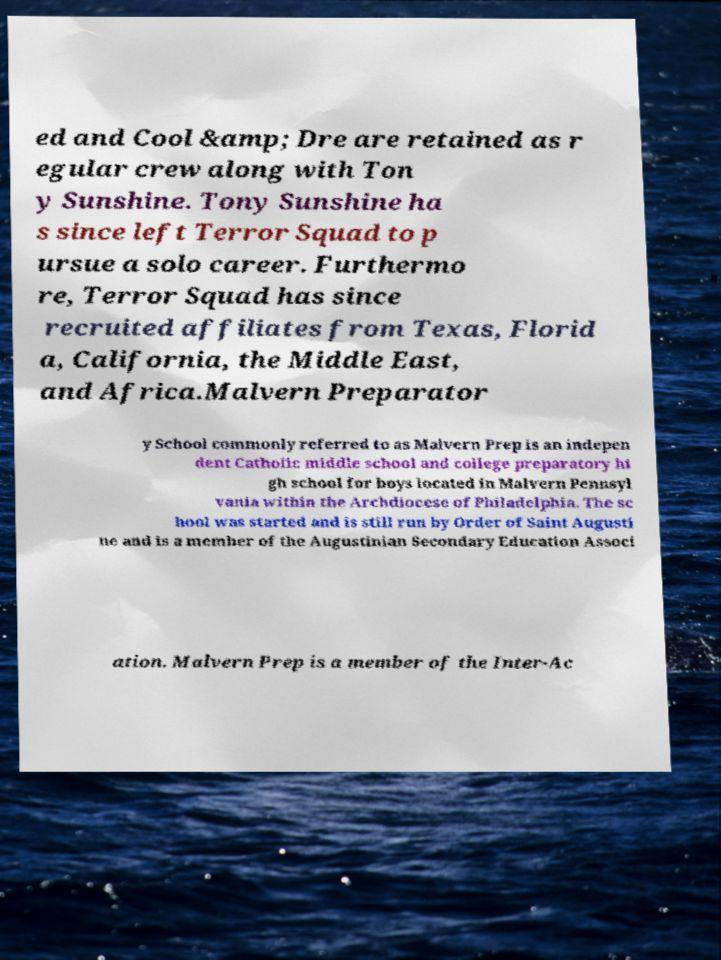Can you accurately transcribe the text from the provided image for me? ed and Cool &amp; Dre are retained as r egular crew along with Ton y Sunshine. Tony Sunshine ha s since left Terror Squad to p ursue a solo career. Furthermo re, Terror Squad has since recruited affiliates from Texas, Florid a, California, the Middle East, and Africa.Malvern Preparator y School commonly referred to as Malvern Prep is an indepen dent Catholic middle school and college preparatory hi gh school for boys located in Malvern Pennsyl vania within the Archdiocese of Philadelphia. The sc hool was started and is still run by Order of Saint Augusti ne and is a member of the Augustinian Secondary Education Associ ation. Malvern Prep is a member of the Inter-Ac 